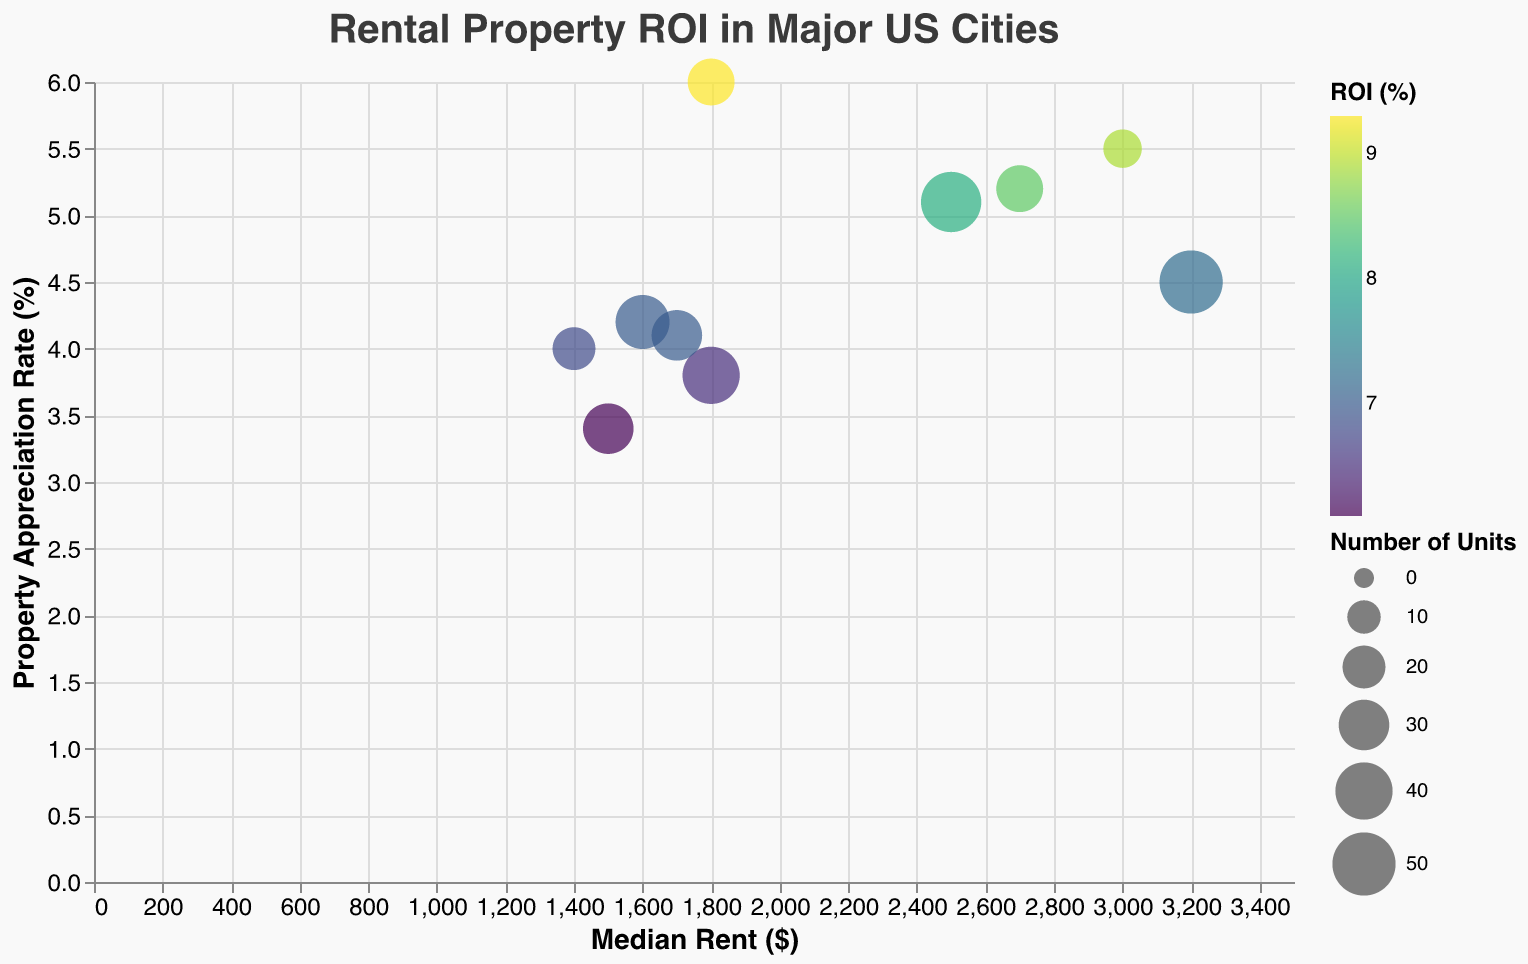What is the title of the chart? The title of the chart is displayed on the top and reads "Rental Property ROI in Major US Cities".
Answer: Rental Property ROI in Major US Cities Which city has the highest ROI? The ROI is depicted by the color of the bubbles, with darker colors representing higher values. The city with the highest ROI is Phoenix (ROI of 9.3%).
Answer: Phoenix What are the median rent and property appreciation rate for San Diego? Hovering over the San Diego bubble shows a tooltip with detailed data including the median rent ($2700) and property appreciation rate (5.2%).
Answer: $2700 and 5.2% Which cities have a property appreciation rate lower than 4%? By checking the y-axis and identifying the bubbles with a property appreciation rate below the 4% mark, the cities are Chicago (3.8%) and Philadelphia (3.4%).
Answer: Chicago and Philadelphia How many cities have a median rent of $1800? Looking along the x-axis for $1800 and counting the bubbles, two cities have this median rent: Chicago and Phoenix.
Answer: 2 What is the relationship between median rent and property appreciation rate in general? Examining the chart, cities with higher median rent do not necessarily have higher property appreciation rates. Each city's position suggests that there's no clear linear trend.
Answer: No clear trend Which city has the most number of units, and how does it compare in ROI to the city with the least number of units? The size of the bubbles indicates the number of units. New York has the most units (50) and San Jose the least (15). New York has an ROI of 7.2%, and San Jose has a higher ROI of 8.9%.
Answer: New York has more units, but San Jose has a higher ROI Is there any city with both high median rent and high property appreciation rate? By checking the upper right portion of the chart, San Diego (Median Rent: $2700, Property Appreciation Rate: 5.2%) and San Jose (Median Rent: $3000, Property Appreciation Rate: 5.5%) fit this criterion.
Answer: San Diego and San Jose What is the average median rent for all cities shown in the chart? Sum all median rent values ($3200 + $2500 + $1800 + $1600 + $1800 + $1500 + $1400 + $2700 + $1700 + $3000) which equals $21200. Divide by the number of cities (10), the average median rent is $21200/10 = $2120.
Answer: $2120 Which city has a lower ROI than Houston but a higher property appreciation rate? Houston has an ROI of 7.0% and a property appreciation rate of 4.2%. Checking the bubbles, Los Angeles fits this criterion (ROI: 8.1%, Property Appreciation Rate: 5.1%).
Answer: Los Angeles 